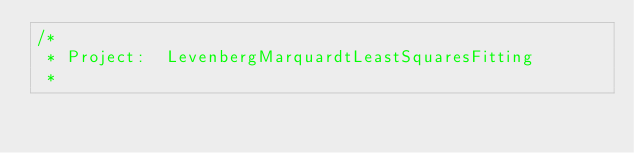<code> <loc_0><loc_0><loc_500><loc_500><_C_>/*
 * Project:  LevenbergMarquardtLeastSquaresFitting
 *</code> 